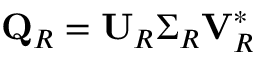<formula> <loc_0><loc_0><loc_500><loc_500>Q _ { R } = U _ { R } \Sigma _ { R } V _ { R } ^ { * }</formula> 